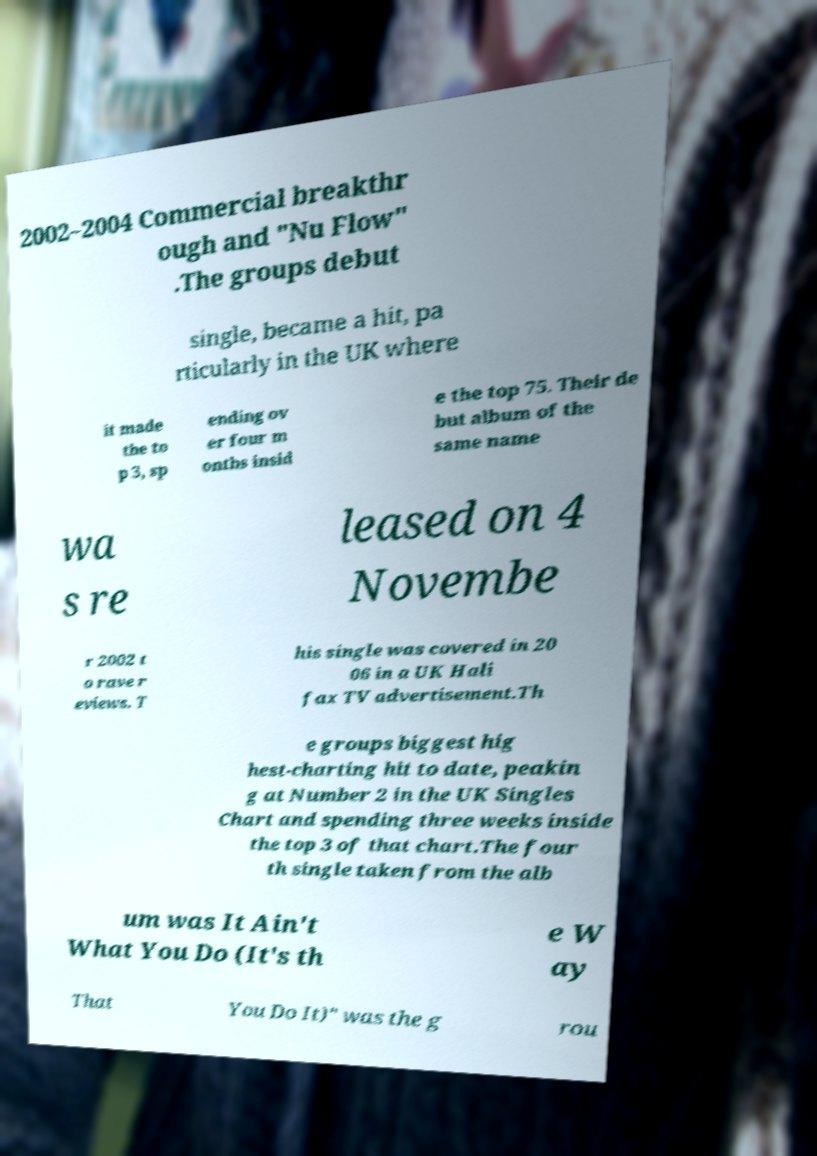Could you assist in decoding the text presented in this image and type it out clearly? 2002–2004 Commercial breakthr ough and "Nu Flow" .The groups debut single, became a hit, pa rticularly in the UK where it made the to p 3, sp ending ov er four m onths insid e the top 75. Their de but album of the same name wa s re leased on 4 Novembe r 2002 t o rave r eviews. T his single was covered in 20 06 in a UK Hali fax TV advertisement.Th e groups biggest hig hest-charting hit to date, peakin g at Number 2 in the UK Singles Chart and spending three weeks inside the top 3 of that chart.The four th single taken from the alb um was It Ain't What You Do (It's th e W ay That You Do It)" was the g rou 